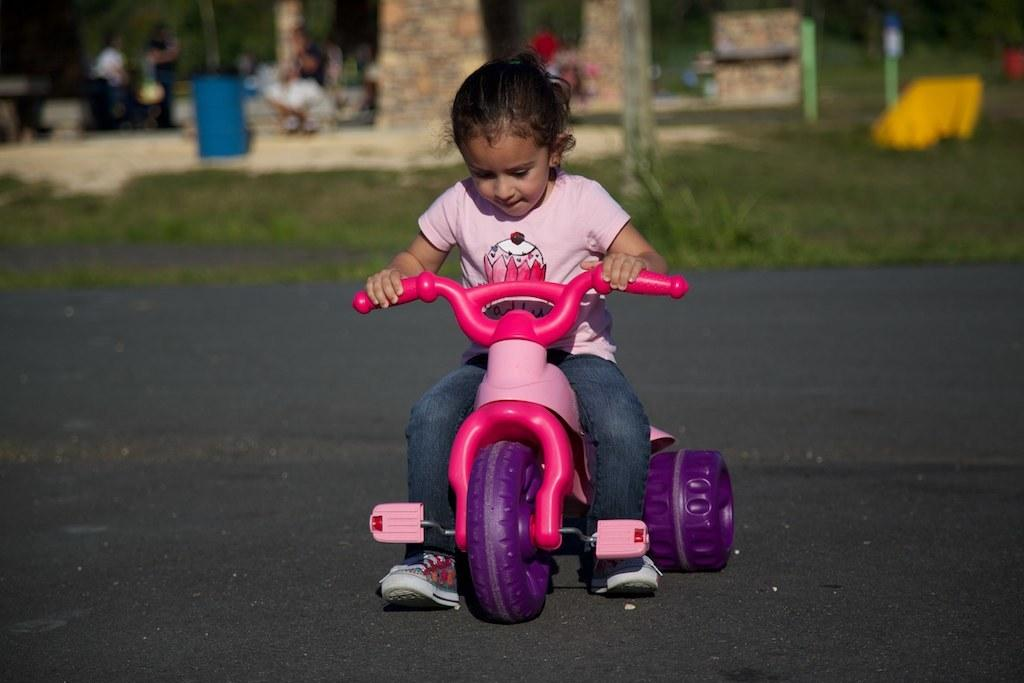Who is the main subject in the image? There is a small girl in the image. What is the girl doing in the image? The girl is riding a bike. Where is the bike located in the image? The bike is on the road. Can you describe the people in the background? There is a person standing and a person sitting in the background. What can be seen in the background besides the people? There is a blue-colored drum and green grass around the area. What type of collar can be seen on the bike in the image? There is no collar present on the bike in the image. 